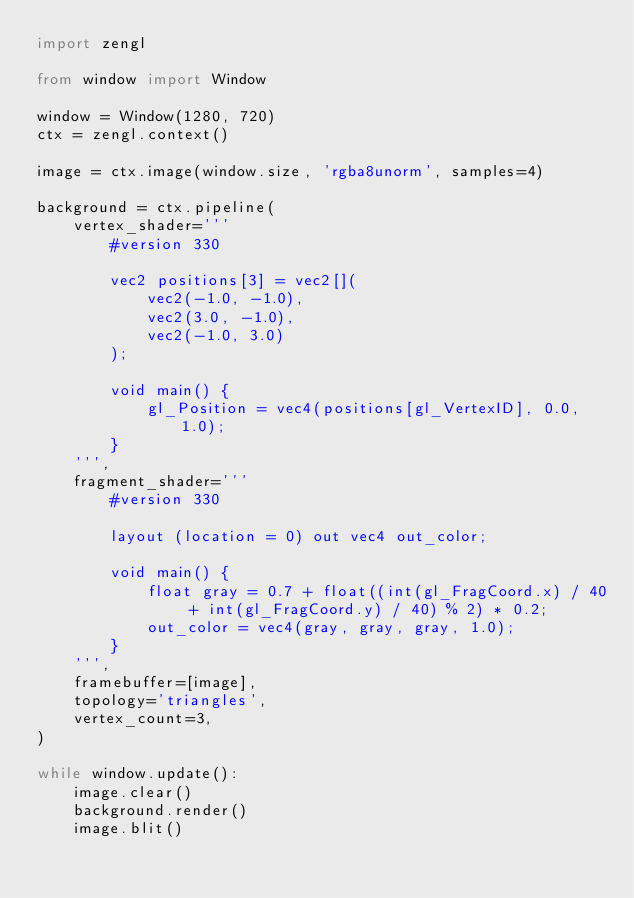Convert code to text. <code><loc_0><loc_0><loc_500><loc_500><_Python_>import zengl

from window import Window

window = Window(1280, 720)
ctx = zengl.context()

image = ctx.image(window.size, 'rgba8unorm', samples=4)

background = ctx.pipeline(
    vertex_shader='''
        #version 330

        vec2 positions[3] = vec2[](
            vec2(-1.0, -1.0),
            vec2(3.0, -1.0),
            vec2(-1.0, 3.0)
        );

        void main() {
            gl_Position = vec4(positions[gl_VertexID], 0.0, 1.0);
        }
    ''',
    fragment_shader='''
        #version 330

        layout (location = 0) out vec4 out_color;

        void main() {
            float gray = 0.7 + float((int(gl_FragCoord.x) / 40 + int(gl_FragCoord.y) / 40) % 2) * 0.2;
            out_color = vec4(gray, gray, gray, 1.0);
        }
    ''',
    framebuffer=[image],
    topology='triangles',
    vertex_count=3,
)

while window.update():
    image.clear()
    background.render()
    image.blit()
</code> 